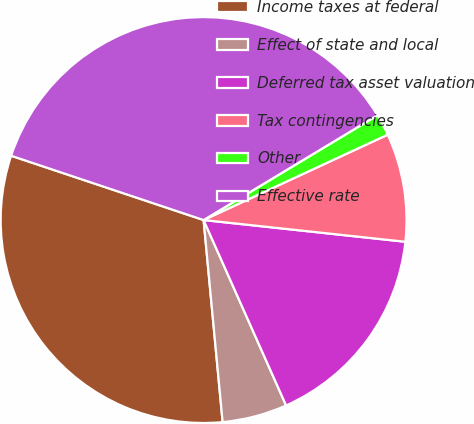<chart> <loc_0><loc_0><loc_500><loc_500><pie_chart><fcel>Income taxes at federal<fcel>Effect of state and local<fcel>Deferred tax asset valuation<fcel>Tax contingencies<fcel>Other<fcel>Effective rate<nl><fcel>31.63%<fcel>5.17%<fcel>16.63%<fcel>8.62%<fcel>1.72%<fcel>36.24%<nl></chart> 